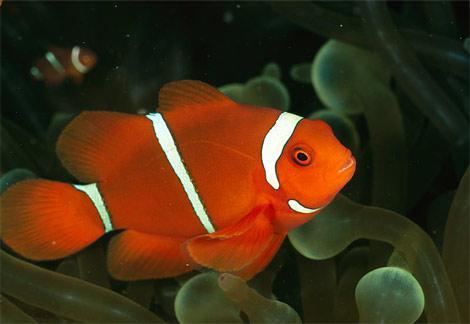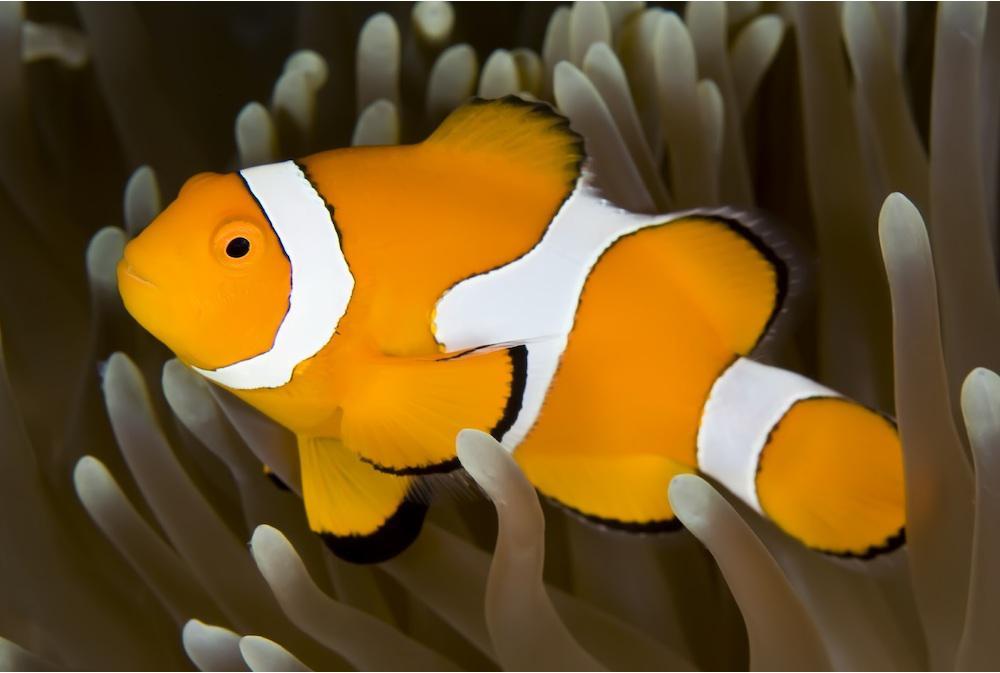The first image is the image on the left, the second image is the image on the right. Examine the images to the left and right. Is the description "The clown fish in the left and right images face toward each other." accurate? Answer yes or no. Yes. 